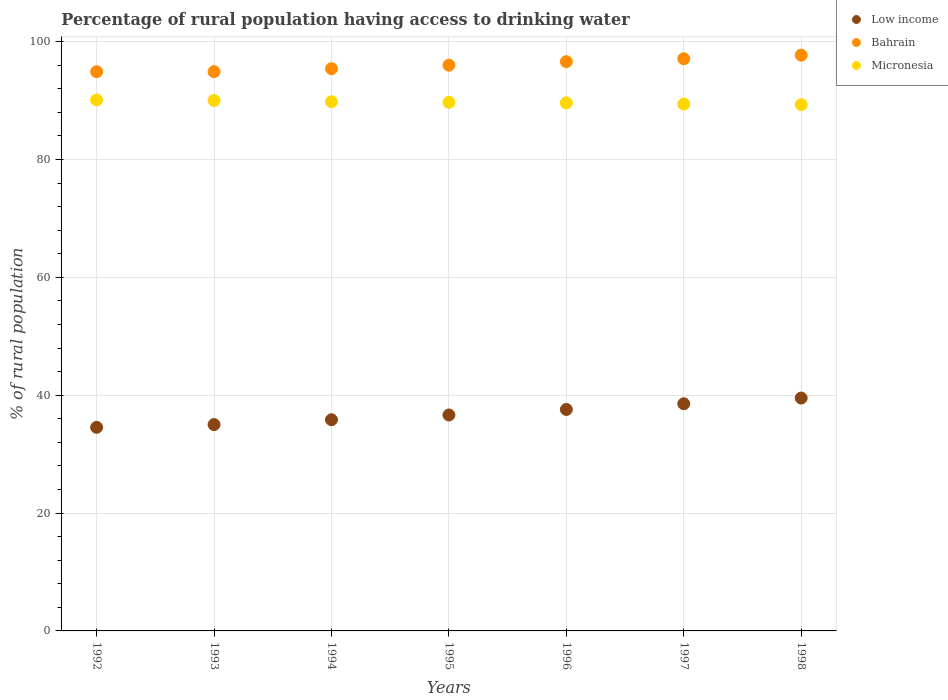How many different coloured dotlines are there?
Give a very brief answer. 3. Is the number of dotlines equal to the number of legend labels?
Provide a short and direct response. Yes. What is the percentage of rural population having access to drinking water in Low income in 1993?
Offer a very short reply. 35.01. Across all years, what is the maximum percentage of rural population having access to drinking water in Low income?
Your answer should be very brief. 39.52. Across all years, what is the minimum percentage of rural population having access to drinking water in Micronesia?
Make the answer very short. 89.3. In which year was the percentage of rural population having access to drinking water in Micronesia maximum?
Provide a short and direct response. 1992. What is the total percentage of rural population having access to drinking water in Low income in the graph?
Provide a short and direct response. 257.69. What is the difference between the percentage of rural population having access to drinking water in Low income in 1995 and that in 1996?
Your response must be concise. -0.94. What is the difference between the percentage of rural population having access to drinking water in Bahrain in 1992 and the percentage of rural population having access to drinking water in Low income in 1994?
Offer a very short reply. 59.07. What is the average percentage of rural population having access to drinking water in Low income per year?
Your answer should be compact. 36.81. In the year 1998, what is the difference between the percentage of rural population having access to drinking water in Low income and percentage of rural population having access to drinking water in Micronesia?
Provide a short and direct response. -49.78. What is the ratio of the percentage of rural population having access to drinking water in Low income in 1992 to that in 1994?
Ensure brevity in your answer.  0.96. Is the difference between the percentage of rural population having access to drinking water in Low income in 1993 and 1998 greater than the difference between the percentage of rural population having access to drinking water in Micronesia in 1993 and 1998?
Offer a very short reply. No. What is the difference between the highest and the second highest percentage of rural population having access to drinking water in Low income?
Give a very brief answer. 0.97. What is the difference between the highest and the lowest percentage of rural population having access to drinking water in Bahrain?
Offer a terse response. 2.8. In how many years, is the percentage of rural population having access to drinking water in Bahrain greater than the average percentage of rural population having access to drinking water in Bahrain taken over all years?
Provide a succinct answer. 3. Is the sum of the percentage of rural population having access to drinking water in Low income in 1993 and 1994 greater than the maximum percentage of rural population having access to drinking water in Bahrain across all years?
Your answer should be very brief. No. Does the percentage of rural population having access to drinking water in Low income monotonically increase over the years?
Your response must be concise. Yes. How many years are there in the graph?
Make the answer very short. 7. What is the difference between two consecutive major ticks on the Y-axis?
Your answer should be very brief. 20. Does the graph contain grids?
Provide a short and direct response. Yes. Where does the legend appear in the graph?
Give a very brief answer. Top right. How many legend labels are there?
Keep it short and to the point. 3. How are the legend labels stacked?
Your answer should be very brief. Vertical. What is the title of the graph?
Offer a very short reply. Percentage of rural population having access to drinking water. What is the label or title of the Y-axis?
Keep it short and to the point. % of rural population. What is the % of rural population in Low income in 1992?
Provide a succinct answer. 34.55. What is the % of rural population in Bahrain in 1992?
Your response must be concise. 94.9. What is the % of rural population in Micronesia in 1992?
Your response must be concise. 90.1. What is the % of rural population of Low income in 1993?
Keep it short and to the point. 35.01. What is the % of rural population of Bahrain in 1993?
Give a very brief answer. 94.9. What is the % of rural population of Low income in 1994?
Ensure brevity in your answer.  35.83. What is the % of rural population of Bahrain in 1994?
Make the answer very short. 95.4. What is the % of rural population in Micronesia in 1994?
Offer a terse response. 89.8. What is the % of rural population in Low income in 1995?
Offer a terse response. 36.64. What is the % of rural population of Bahrain in 1995?
Provide a succinct answer. 96. What is the % of rural population in Micronesia in 1995?
Your response must be concise. 89.7. What is the % of rural population of Low income in 1996?
Your answer should be compact. 37.58. What is the % of rural population of Bahrain in 1996?
Make the answer very short. 96.6. What is the % of rural population of Micronesia in 1996?
Keep it short and to the point. 89.6. What is the % of rural population of Low income in 1997?
Offer a terse response. 38.55. What is the % of rural population of Bahrain in 1997?
Offer a terse response. 97.1. What is the % of rural population in Micronesia in 1997?
Ensure brevity in your answer.  89.4. What is the % of rural population in Low income in 1998?
Offer a terse response. 39.52. What is the % of rural population in Bahrain in 1998?
Provide a succinct answer. 97.7. What is the % of rural population of Micronesia in 1998?
Your response must be concise. 89.3. Across all years, what is the maximum % of rural population of Low income?
Give a very brief answer. 39.52. Across all years, what is the maximum % of rural population in Bahrain?
Ensure brevity in your answer.  97.7. Across all years, what is the maximum % of rural population of Micronesia?
Offer a terse response. 90.1. Across all years, what is the minimum % of rural population in Low income?
Keep it short and to the point. 34.55. Across all years, what is the minimum % of rural population in Bahrain?
Keep it short and to the point. 94.9. Across all years, what is the minimum % of rural population of Micronesia?
Ensure brevity in your answer.  89.3. What is the total % of rural population of Low income in the graph?
Ensure brevity in your answer.  257.69. What is the total % of rural population in Bahrain in the graph?
Provide a short and direct response. 672.6. What is the total % of rural population of Micronesia in the graph?
Provide a succinct answer. 627.9. What is the difference between the % of rural population in Low income in 1992 and that in 1993?
Offer a terse response. -0.46. What is the difference between the % of rural population in Micronesia in 1992 and that in 1993?
Provide a short and direct response. 0.1. What is the difference between the % of rural population of Low income in 1992 and that in 1994?
Offer a terse response. -1.28. What is the difference between the % of rural population in Bahrain in 1992 and that in 1994?
Your answer should be very brief. -0.5. What is the difference between the % of rural population of Low income in 1992 and that in 1995?
Provide a short and direct response. -2.09. What is the difference between the % of rural population of Low income in 1992 and that in 1996?
Your answer should be compact. -3.03. What is the difference between the % of rural population in Bahrain in 1992 and that in 1996?
Provide a succinct answer. -1.7. What is the difference between the % of rural population of Micronesia in 1992 and that in 1996?
Your answer should be very brief. 0.5. What is the difference between the % of rural population in Low income in 1992 and that in 1997?
Your answer should be very brief. -4. What is the difference between the % of rural population in Bahrain in 1992 and that in 1997?
Ensure brevity in your answer.  -2.2. What is the difference between the % of rural population in Low income in 1992 and that in 1998?
Your response must be concise. -4.97. What is the difference between the % of rural population in Low income in 1993 and that in 1994?
Offer a terse response. -0.82. What is the difference between the % of rural population in Bahrain in 1993 and that in 1994?
Keep it short and to the point. -0.5. What is the difference between the % of rural population in Micronesia in 1993 and that in 1994?
Your answer should be very brief. 0.2. What is the difference between the % of rural population in Low income in 1993 and that in 1995?
Keep it short and to the point. -1.63. What is the difference between the % of rural population of Low income in 1993 and that in 1996?
Offer a terse response. -2.57. What is the difference between the % of rural population in Micronesia in 1993 and that in 1996?
Provide a short and direct response. 0.4. What is the difference between the % of rural population of Low income in 1993 and that in 1997?
Your answer should be very brief. -3.53. What is the difference between the % of rural population of Bahrain in 1993 and that in 1997?
Offer a terse response. -2.2. What is the difference between the % of rural population in Micronesia in 1993 and that in 1997?
Make the answer very short. 0.6. What is the difference between the % of rural population of Low income in 1993 and that in 1998?
Provide a short and direct response. -4.5. What is the difference between the % of rural population of Bahrain in 1993 and that in 1998?
Provide a short and direct response. -2.8. What is the difference between the % of rural population in Micronesia in 1993 and that in 1998?
Make the answer very short. 0.7. What is the difference between the % of rural population of Low income in 1994 and that in 1995?
Offer a terse response. -0.81. What is the difference between the % of rural population in Bahrain in 1994 and that in 1995?
Offer a very short reply. -0.6. What is the difference between the % of rural population in Micronesia in 1994 and that in 1995?
Your answer should be very brief. 0.1. What is the difference between the % of rural population in Low income in 1994 and that in 1996?
Your answer should be very brief. -1.74. What is the difference between the % of rural population in Low income in 1994 and that in 1997?
Ensure brevity in your answer.  -2.71. What is the difference between the % of rural population of Micronesia in 1994 and that in 1997?
Your response must be concise. 0.4. What is the difference between the % of rural population of Low income in 1994 and that in 1998?
Offer a very short reply. -3.68. What is the difference between the % of rural population of Bahrain in 1994 and that in 1998?
Make the answer very short. -2.3. What is the difference between the % of rural population of Low income in 1995 and that in 1996?
Provide a succinct answer. -0.94. What is the difference between the % of rural population in Micronesia in 1995 and that in 1996?
Offer a terse response. 0.1. What is the difference between the % of rural population of Low income in 1995 and that in 1997?
Give a very brief answer. -1.9. What is the difference between the % of rural population of Low income in 1995 and that in 1998?
Your answer should be very brief. -2.87. What is the difference between the % of rural population in Bahrain in 1995 and that in 1998?
Offer a very short reply. -1.7. What is the difference between the % of rural population of Micronesia in 1995 and that in 1998?
Make the answer very short. 0.4. What is the difference between the % of rural population of Low income in 1996 and that in 1997?
Your answer should be very brief. -0.97. What is the difference between the % of rural population in Bahrain in 1996 and that in 1997?
Make the answer very short. -0.5. What is the difference between the % of rural population in Micronesia in 1996 and that in 1997?
Offer a very short reply. 0.2. What is the difference between the % of rural population of Low income in 1996 and that in 1998?
Provide a succinct answer. -1.94. What is the difference between the % of rural population of Low income in 1997 and that in 1998?
Offer a very short reply. -0.97. What is the difference between the % of rural population in Bahrain in 1997 and that in 1998?
Your answer should be compact. -0.6. What is the difference between the % of rural population of Micronesia in 1997 and that in 1998?
Offer a very short reply. 0.1. What is the difference between the % of rural population of Low income in 1992 and the % of rural population of Bahrain in 1993?
Make the answer very short. -60.35. What is the difference between the % of rural population of Low income in 1992 and the % of rural population of Micronesia in 1993?
Ensure brevity in your answer.  -55.45. What is the difference between the % of rural population of Low income in 1992 and the % of rural population of Bahrain in 1994?
Keep it short and to the point. -60.85. What is the difference between the % of rural population of Low income in 1992 and the % of rural population of Micronesia in 1994?
Ensure brevity in your answer.  -55.25. What is the difference between the % of rural population in Low income in 1992 and the % of rural population in Bahrain in 1995?
Offer a very short reply. -61.45. What is the difference between the % of rural population in Low income in 1992 and the % of rural population in Micronesia in 1995?
Your answer should be very brief. -55.15. What is the difference between the % of rural population of Bahrain in 1992 and the % of rural population of Micronesia in 1995?
Offer a terse response. 5.2. What is the difference between the % of rural population of Low income in 1992 and the % of rural population of Bahrain in 1996?
Provide a succinct answer. -62.05. What is the difference between the % of rural population of Low income in 1992 and the % of rural population of Micronesia in 1996?
Your response must be concise. -55.05. What is the difference between the % of rural population in Low income in 1992 and the % of rural population in Bahrain in 1997?
Give a very brief answer. -62.55. What is the difference between the % of rural population in Low income in 1992 and the % of rural population in Micronesia in 1997?
Your response must be concise. -54.85. What is the difference between the % of rural population in Low income in 1992 and the % of rural population in Bahrain in 1998?
Ensure brevity in your answer.  -63.15. What is the difference between the % of rural population of Low income in 1992 and the % of rural population of Micronesia in 1998?
Keep it short and to the point. -54.75. What is the difference between the % of rural population of Low income in 1993 and the % of rural population of Bahrain in 1994?
Provide a succinct answer. -60.39. What is the difference between the % of rural population in Low income in 1993 and the % of rural population in Micronesia in 1994?
Ensure brevity in your answer.  -54.79. What is the difference between the % of rural population in Low income in 1993 and the % of rural population in Bahrain in 1995?
Provide a succinct answer. -60.99. What is the difference between the % of rural population of Low income in 1993 and the % of rural population of Micronesia in 1995?
Your response must be concise. -54.69. What is the difference between the % of rural population of Bahrain in 1993 and the % of rural population of Micronesia in 1995?
Offer a very short reply. 5.2. What is the difference between the % of rural population of Low income in 1993 and the % of rural population of Bahrain in 1996?
Provide a short and direct response. -61.59. What is the difference between the % of rural population in Low income in 1993 and the % of rural population in Micronesia in 1996?
Offer a very short reply. -54.59. What is the difference between the % of rural population of Bahrain in 1993 and the % of rural population of Micronesia in 1996?
Your answer should be very brief. 5.3. What is the difference between the % of rural population of Low income in 1993 and the % of rural population of Bahrain in 1997?
Make the answer very short. -62.09. What is the difference between the % of rural population of Low income in 1993 and the % of rural population of Micronesia in 1997?
Offer a terse response. -54.39. What is the difference between the % of rural population of Bahrain in 1993 and the % of rural population of Micronesia in 1997?
Your response must be concise. 5.5. What is the difference between the % of rural population in Low income in 1993 and the % of rural population in Bahrain in 1998?
Your answer should be very brief. -62.69. What is the difference between the % of rural population of Low income in 1993 and the % of rural population of Micronesia in 1998?
Keep it short and to the point. -54.29. What is the difference between the % of rural population in Low income in 1994 and the % of rural population in Bahrain in 1995?
Your answer should be very brief. -60.17. What is the difference between the % of rural population of Low income in 1994 and the % of rural population of Micronesia in 1995?
Make the answer very short. -53.87. What is the difference between the % of rural population in Low income in 1994 and the % of rural population in Bahrain in 1996?
Your response must be concise. -60.77. What is the difference between the % of rural population of Low income in 1994 and the % of rural population of Micronesia in 1996?
Provide a short and direct response. -53.77. What is the difference between the % of rural population of Low income in 1994 and the % of rural population of Bahrain in 1997?
Your answer should be very brief. -61.27. What is the difference between the % of rural population in Low income in 1994 and the % of rural population in Micronesia in 1997?
Your answer should be very brief. -53.57. What is the difference between the % of rural population in Low income in 1994 and the % of rural population in Bahrain in 1998?
Ensure brevity in your answer.  -61.87. What is the difference between the % of rural population of Low income in 1994 and the % of rural population of Micronesia in 1998?
Ensure brevity in your answer.  -53.47. What is the difference between the % of rural population of Low income in 1995 and the % of rural population of Bahrain in 1996?
Your answer should be very brief. -59.96. What is the difference between the % of rural population of Low income in 1995 and the % of rural population of Micronesia in 1996?
Your answer should be compact. -52.96. What is the difference between the % of rural population in Bahrain in 1995 and the % of rural population in Micronesia in 1996?
Provide a succinct answer. 6.4. What is the difference between the % of rural population of Low income in 1995 and the % of rural population of Bahrain in 1997?
Make the answer very short. -60.46. What is the difference between the % of rural population in Low income in 1995 and the % of rural population in Micronesia in 1997?
Ensure brevity in your answer.  -52.76. What is the difference between the % of rural population in Bahrain in 1995 and the % of rural population in Micronesia in 1997?
Your answer should be very brief. 6.6. What is the difference between the % of rural population of Low income in 1995 and the % of rural population of Bahrain in 1998?
Your answer should be compact. -61.06. What is the difference between the % of rural population of Low income in 1995 and the % of rural population of Micronesia in 1998?
Provide a succinct answer. -52.66. What is the difference between the % of rural population of Low income in 1996 and the % of rural population of Bahrain in 1997?
Make the answer very short. -59.52. What is the difference between the % of rural population of Low income in 1996 and the % of rural population of Micronesia in 1997?
Provide a succinct answer. -51.82. What is the difference between the % of rural population in Low income in 1996 and the % of rural population in Bahrain in 1998?
Keep it short and to the point. -60.12. What is the difference between the % of rural population of Low income in 1996 and the % of rural population of Micronesia in 1998?
Your response must be concise. -51.72. What is the difference between the % of rural population in Low income in 1997 and the % of rural population in Bahrain in 1998?
Your answer should be compact. -59.15. What is the difference between the % of rural population in Low income in 1997 and the % of rural population in Micronesia in 1998?
Your answer should be compact. -50.75. What is the average % of rural population in Low income per year?
Keep it short and to the point. 36.81. What is the average % of rural population in Bahrain per year?
Provide a succinct answer. 96.09. What is the average % of rural population of Micronesia per year?
Ensure brevity in your answer.  89.7. In the year 1992, what is the difference between the % of rural population in Low income and % of rural population in Bahrain?
Give a very brief answer. -60.35. In the year 1992, what is the difference between the % of rural population in Low income and % of rural population in Micronesia?
Offer a terse response. -55.55. In the year 1993, what is the difference between the % of rural population in Low income and % of rural population in Bahrain?
Your answer should be compact. -59.89. In the year 1993, what is the difference between the % of rural population in Low income and % of rural population in Micronesia?
Provide a short and direct response. -54.99. In the year 1993, what is the difference between the % of rural population in Bahrain and % of rural population in Micronesia?
Make the answer very short. 4.9. In the year 1994, what is the difference between the % of rural population in Low income and % of rural population in Bahrain?
Ensure brevity in your answer.  -59.57. In the year 1994, what is the difference between the % of rural population of Low income and % of rural population of Micronesia?
Give a very brief answer. -53.97. In the year 1994, what is the difference between the % of rural population of Bahrain and % of rural population of Micronesia?
Give a very brief answer. 5.6. In the year 1995, what is the difference between the % of rural population of Low income and % of rural population of Bahrain?
Offer a terse response. -59.36. In the year 1995, what is the difference between the % of rural population of Low income and % of rural population of Micronesia?
Make the answer very short. -53.06. In the year 1995, what is the difference between the % of rural population of Bahrain and % of rural population of Micronesia?
Keep it short and to the point. 6.3. In the year 1996, what is the difference between the % of rural population of Low income and % of rural population of Bahrain?
Provide a succinct answer. -59.02. In the year 1996, what is the difference between the % of rural population in Low income and % of rural population in Micronesia?
Your answer should be very brief. -52.02. In the year 1996, what is the difference between the % of rural population of Bahrain and % of rural population of Micronesia?
Ensure brevity in your answer.  7. In the year 1997, what is the difference between the % of rural population in Low income and % of rural population in Bahrain?
Give a very brief answer. -58.55. In the year 1997, what is the difference between the % of rural population in Low income and % of rural population in Micronesia?
Ensure brevity in your answer.  -50.85. In the year 1997, what is the difference between the % of rural population of Bahrain and % of rural population of Micronesia?
Offer a terse response. 7.7. In the year 1998, what is the difference between the % of rural population in Low income and % of rural population in Bahrain?
Your response must be concise. -58.18. In the year 1998, what is the difference between the % of rural population of Low income and % of rural population of Micronesia?
Keep it short and to the point. -49.78. What is the ratio of the % of rural population in Low income in 1992 to that in 1993?
Provide a short and direct response. 0.99. What is the ratio of the % of rural population of Micronesia in 1992 to that in 1993?
Provide a short and direct response. 1. What is the ratio of the % of rural population of Low income in 1992 to that in 1994?
Your answer should be compact. 0.96. What is the ratio of the % of rural population in Bahrain in 1992 to that in 1994?
Your response must be concise. 0.99. What is the ratio of the % of rural population of Low income in 1992 to that in 1995?
Your answer should be very brief. 0.94. What is the ratio of the % of rural population in Bahrain in 1992 to that in 1995?
Make the answer very short. 0.99. What is the ratio of the % of rural population in Micronesia in 1992 to that in 1995?
Your response must be concise. 1. What is the ratio of the % of rural population in Low income in 1992 to that in 1996?
Your answer should be very brief. 0.92. What is the ratio of the % of rural population in Bahrain in 1992 to that in 1996?
Your answer should be very brief. 0.98. What is the ratio of the % of rural population of Micronesia in 1992 to that in 1996?
Make the answer very short. 1.01. What is the ratio of the % of rural population in Low income in 1992 to that in 1997?
Provide a short and direct response. 0.9. What is the ratio of the % of rural population in Bahrain in 1992 to that in 1997?
Offer a terse response. 0.98. What is the ratio of the % of rural population in Micronesia in 1992 to that in 1997?
Provide a short and direct response. 1.01. What is the ratio of the % of rural population of Low income in 1992 to that in 1998?
Your answer should be compact. 0.87. What is the ratio of the % of rural population of Bahrain in 1992 to that in 1998?
Offer a very short reply. 0.97. What is the ratio of the % of rural population of Low income in 1993 to that in 1994?
Offer a very short reply. 0.98. What is the ratio of the % of rural population of Low income in 1993 to that in 1995?
Keep it short and to the point. 0.96. What is the ratio of the % of rural population of Bahrain in 1993 to that in 1995?
Your response must be concise. 0.99. What is the ratio of the % of rural population of Micronesia in 1993 to that in 1995?
Provide a succinct answer. 1. What is the ratio of the % of rural population in Low income in 1993 to that in 1996?
Provide a short and direct response. 0.93. What is the ratio of the % of rural population of Bahrain in 1993 to that in 1996?
Provide a short and direct response. 0.98. What is the ratio of the % of rural population in Micronesia in 1993 to that in 1996?
Your answer should be compact. 1. What is the ratio of the % of rural population in Low income in 1993 to that in 1997?
Ensure brevity in your answer.  0.91. What is the ratio of the % of rural population in Bahrain in 1993 to that in 1997?
Your response must be concise. 0.98. What is the ratio of the % of rural population of Micronesia in 1993 to that in 1997?
Keep it short and to the point. 1.01. What is the ratio of the % of rural population in Low income in 1993 to that in 1998?
Your answer should be compact. 0.89. What is the ratio of the % of rural population of Bahrain in 1993 to that in 1998?
Provide a succinct answer. 0.97. What is the ratio of the % of rural population in Low income in 1994 to that in 1995?
Provide a succinct answer. 0.98. What is the ratio of the % of rural population of Bahrain in 1994 to that in 1995?
Provide a short and direct response. 0.99. What is the ratio of the % of rural population of Low income in 1994 to that in 1996?
Offer a very short reply. 0.95. What is the ratio of the % of rural population in Bahrain in 1994 to that in 1996?
Ensure brevity in your answer.  0.99. What is the ratio of the % of rural population in Micronesia in 1994 to that in 1996?
Provide a succinct answer. 1. What is the ratio of the % of rural population of Low income in 1994 to that in 1997?
Keep it short and to the point. 0.93. What is the ratio of the % of rural population of Bahrain in 1994 to that in 1997?
Your answer should be very brief. 0.98. What is the ratio of the % of rural population in Low income in 1994 to that in 1998?
Offer a terse response. 0.91. What is the ratio of the % of rural population of Bahrain in 1994 to that in 1998?
Your response must be concise. 0.98. What is the ratio of the % of rural population in Micronesia in 1994 to that in 1998?
Provide a succinct answer. 1.01. What is the ratio of the % of rural population of Low income in 1995 to that in 1996?
Your answer should be very brief. 0.98. What is the ratio of the % of rural population in Bahrain in 1995 to that in 1996?
Provide a short and direct response. 0.99. What is the ratio of the % of rural population in Low income in 1995 to that in 1997?
Your answer should be very brief. 0.95. What is the ratio of the % of rural population of Bahrain in 1995 to that in 1997?
Provide a short and direct response. 0.99. What is the ratio of the % of rural population of Micronesia in 1995 to that in 1997?
Ensure brevity in your answer.  1. What is the ratio of the % of rural population in Low income in 1995 to that in 1998?
Your answer should be compact. 0.93. What is the ratio of the % of rural population in Bahrain in 1995 to that in 1998?
Offer a terse response. 0.98. What is the ratio of the % of rural population in Micronesia in 1995 to that in 1998?
Ensure brevity in your answer.  1. What is the ratio of the % of rural population in Low income in 1996 to that in 1997?
Ensure brevity in your answer.  0.97. What is the ratio of the % of rural population in Low income in 1996 to that in 1998?
Provide a succinct answer. 0.95. What is the ratio of the % of rural population of Bahrain in 1996 to that in 1998?
Ensure brevity in your answer.  0.99. What is the ratio of the % of rural population of Micronesia in 1996 to that in 1998?
Provide a short and direct response. 1. What is the ratio of the % of rural population in Low income in 1997 to that in 1998?
Your response must be concise. 0.98. What is the difference between the highest and the second highest % of rural population of Low income?
Offer a very short reply. 0.97. What is the difference between the highest and the second highest % of rural population in Bahrain?
Keep it short and to the point. 0.6. What is the difference between the highest and the second highest % of rural population in Micronesia?
Your response must be concise. 0.1. What is the difference between the highest and the lowest % of rural population of Low income?
Give a very brief answer. 4.97. What is the difference between the highest and the lowest % of rural population of Bahrain?
Ensure brevity in your answer.  2.8. 